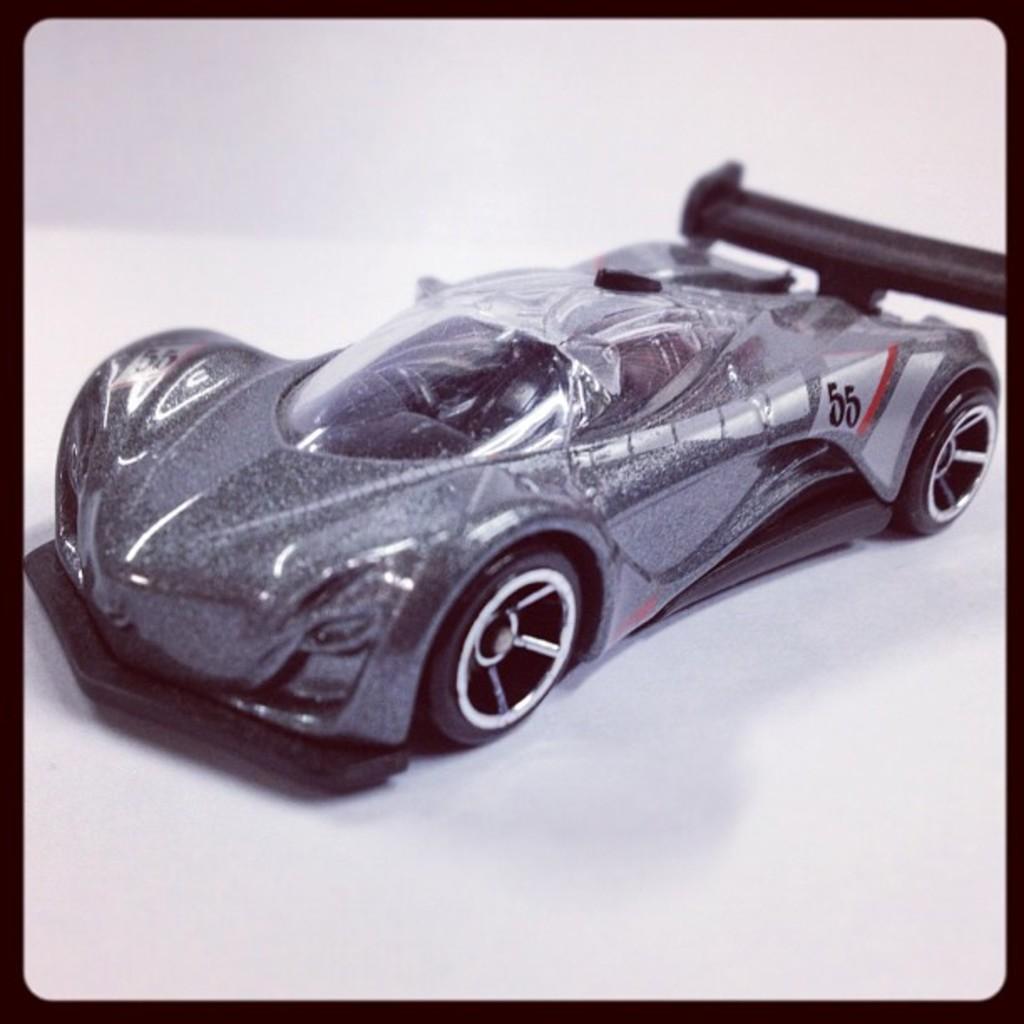What number is on the side of this toy car?
Offer a very short reply. 55. 